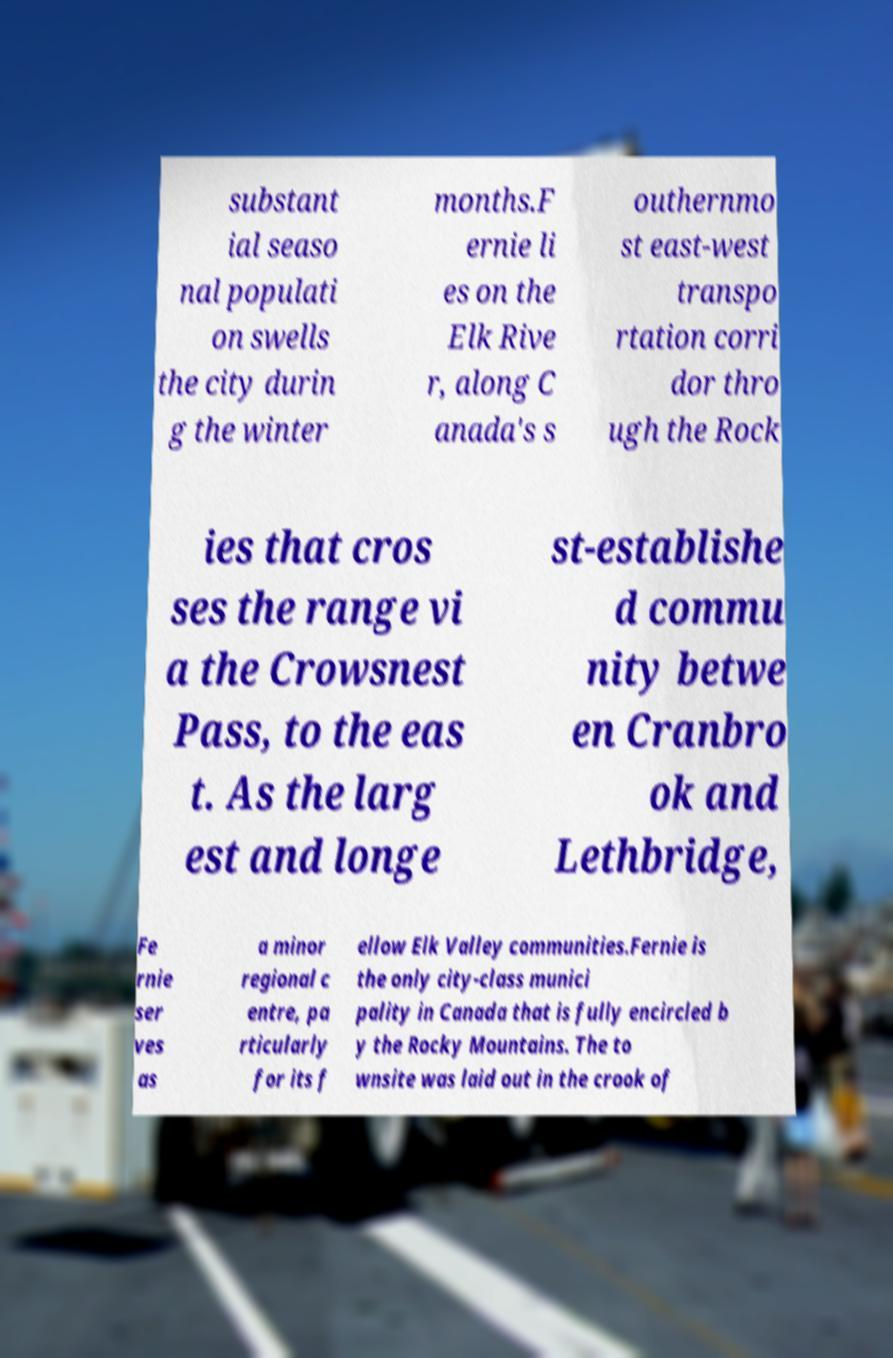Could you assist in decoding the text presented in this image and type it out clearly? substant ial seaso nal populati on swells the city durin g the winter months.F ernie li es on the Elk Rive r, along C anada's s outhernmo st east-west transpo rtation corri dor thro ugh the Rock ies that cros ses the range vi a the Crowsnest Pass, to the eas t. As the larg est and longe st-establishe d commu nity betwe en Cranbro ok and Lethbridge, Fe rnie ser ves as a minor regional c entre, pa rticularly for its f ellow Elk Valley communities.Fernie is the only city-class munici pality in Canada that is fully encircled b y the Rocky Mountains. The to wnsite was laid out in the crook of 